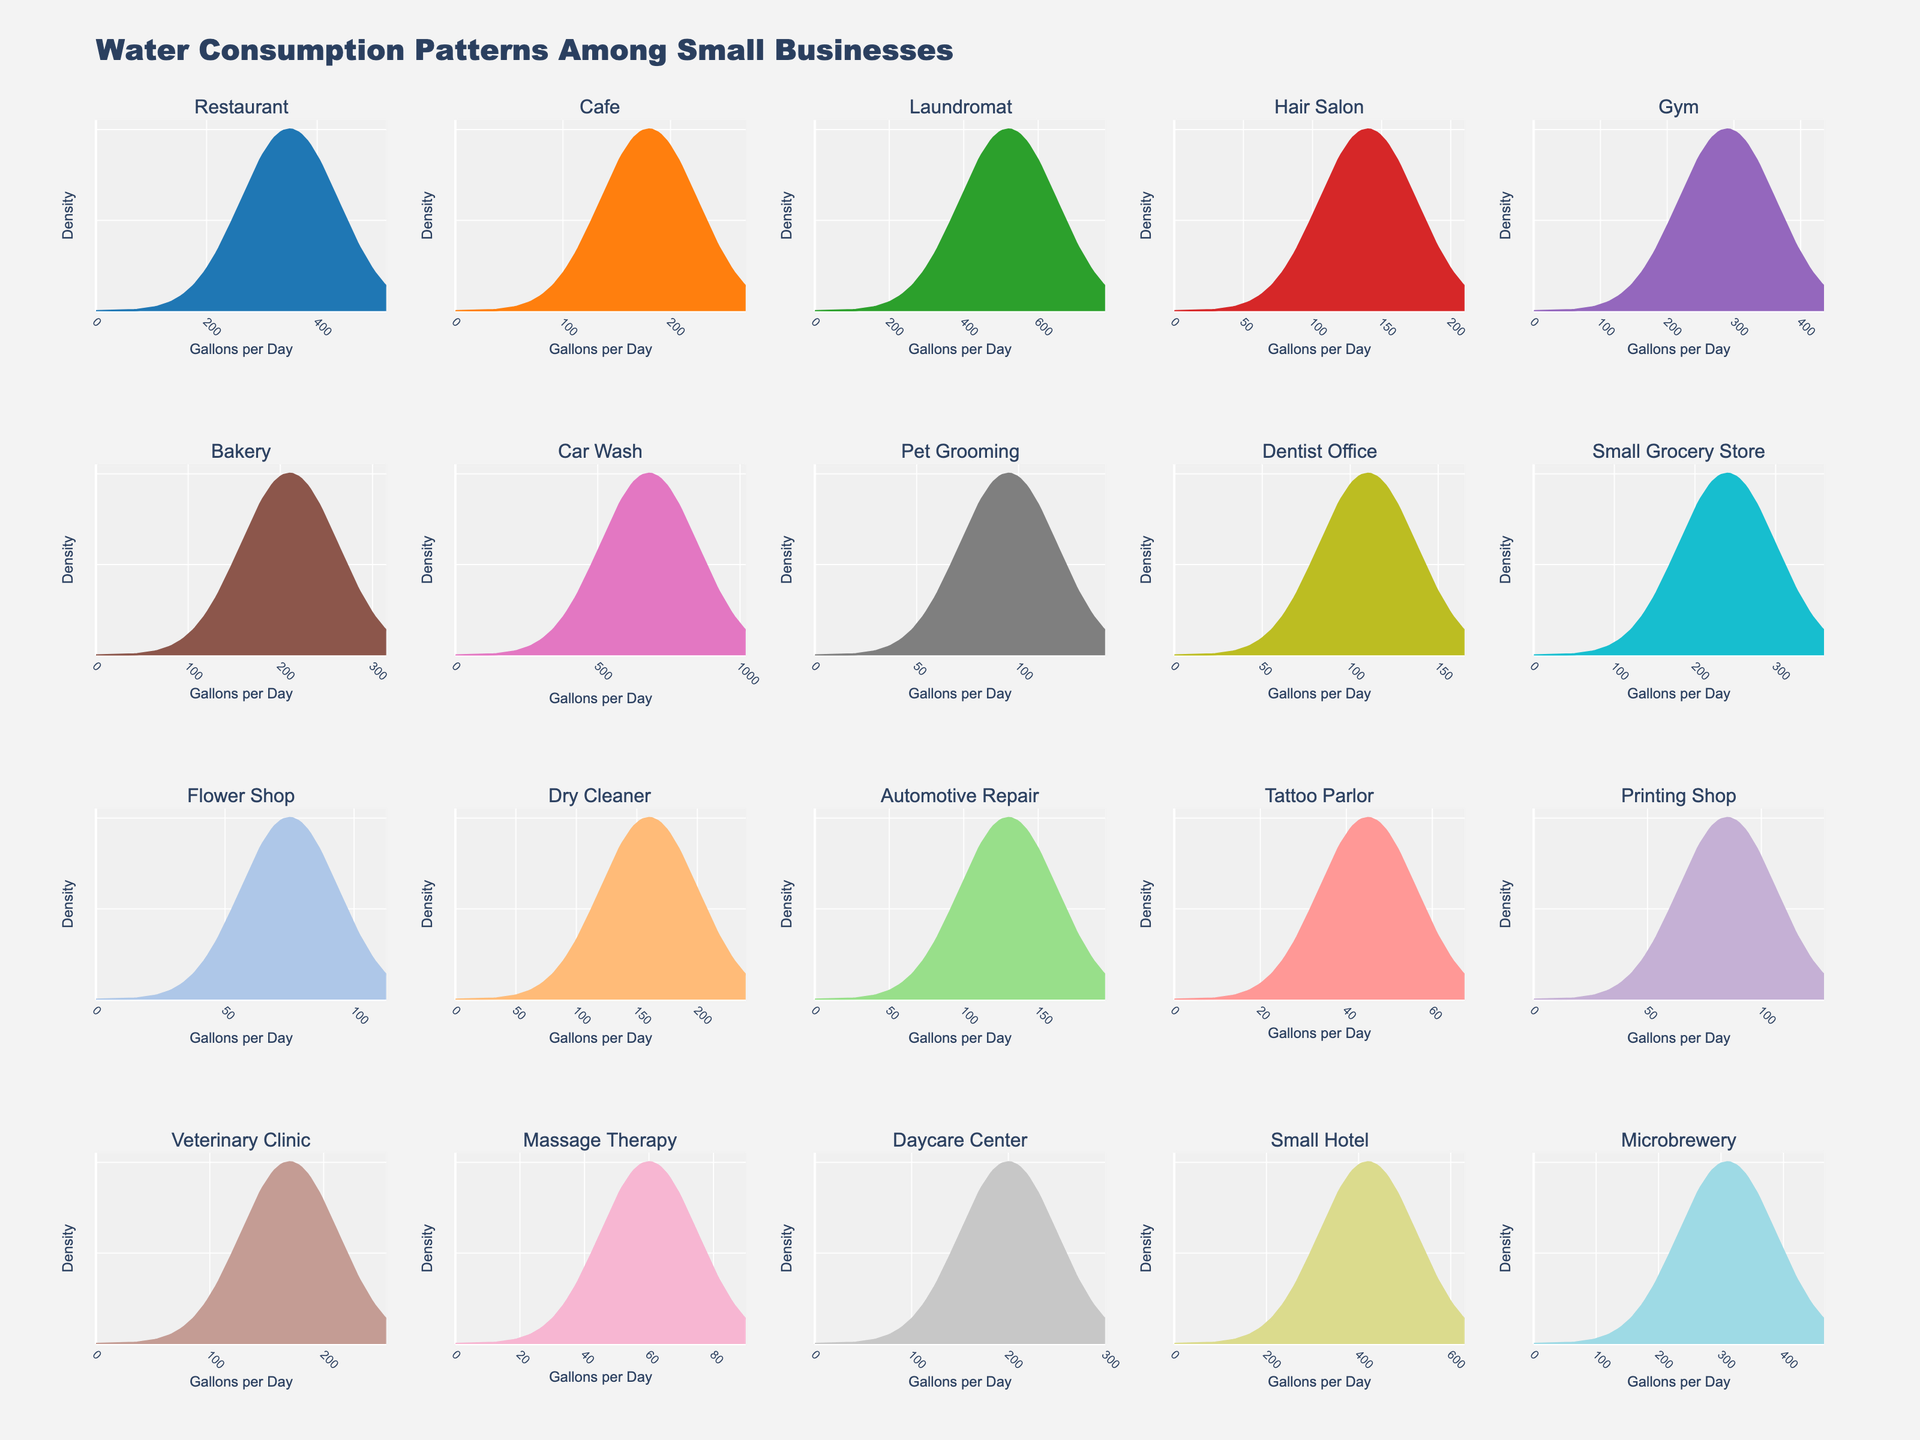Which business type has the highest water consumption per day? By examining the density plots, identify the subplot with the peak located farthest to the right. This represents the highest water consumption per day.
Answer: Car Wash What is the mean water consumption for the following sectors: Restaurant, Cafe, and Gym? First, find the water consumption values for each sector (Restaurant: 350, Cafe: 180, Gym: 290). Then sum these values and divide by the number of sectors: (350 + 180 + 290) / 3 = 273.33
Answer: 273.33 gallons per day Which two business types have the closest water consumption values? Identify the peaks of each density plot and compare their water consumption values to find the pair with the smallest difference. The closest values come from the Dry Cleaner (160) and Veterinary Clinic (170).
Answer: Dry Cleaner and Veterinary Clinic Are there any business sectors with a water consumption less than 100 gallons per day? Look at the subplots and identify any peaks that are located towards the left and below 100 gallons. The Tattoo Parlor, Pet Grooming, Printing Shop, and Flower Shop all have water consumption less than 100 gallons per day.
Answer: Yes What is the range of water consumption values for these businesses? Identify the minimum and maximum values of the peaks across all density plots. The minimum is from Tattoo Parlor (45) and the maximum from Car Wash (680). Calculate the range as 680 - 45.
Answer: 635 gallons per day 